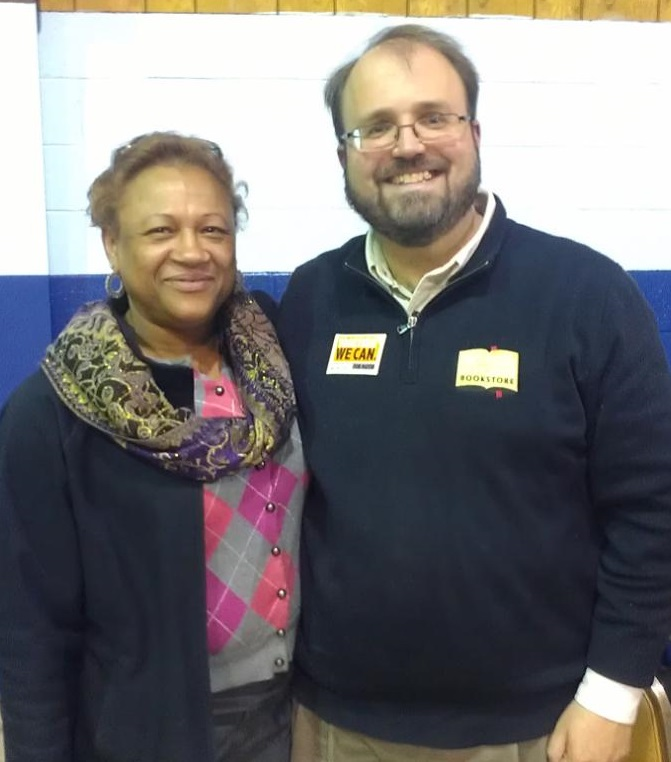What might be the significance of the badges they are wearing? The badges worn by the individuals likely indicate their involvement in the event or organization. They could be name tags and identification for event attendees, volunteers, or organizers. The badges could also symbolize special recognition or honors bestowed upon them for their contributions or status within the community or organization. Based on their interaction, how do you think the individuals know each other? Considering their close proximity and the evident camaraderie between the two individuals, it is likely that they are longtime friends or colleagues involved in similar community activities or initiatives. Their shared experience and mutual respect suggest a strong bond forged through years of collaboration and shared passion for their community's well-being. 